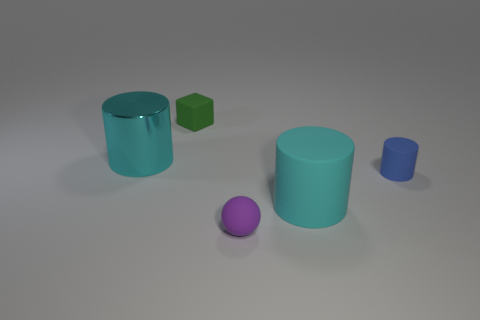Add 2 small blue rubber objects. How many objects exist? 7 Subtract all cubes. How many objects are left? 4 Add 4 large metallic cylinders. How many large metallic cylinders are left? 5 Add 1 tiny green metallic spheres. How many tiny green metallic spheres exist? 1 Subtract 0 yellow cylinders. How many objects are left? 5 Subtract all small green blocks. Subtract all tiny green rubber things. How many objects are left? 3 